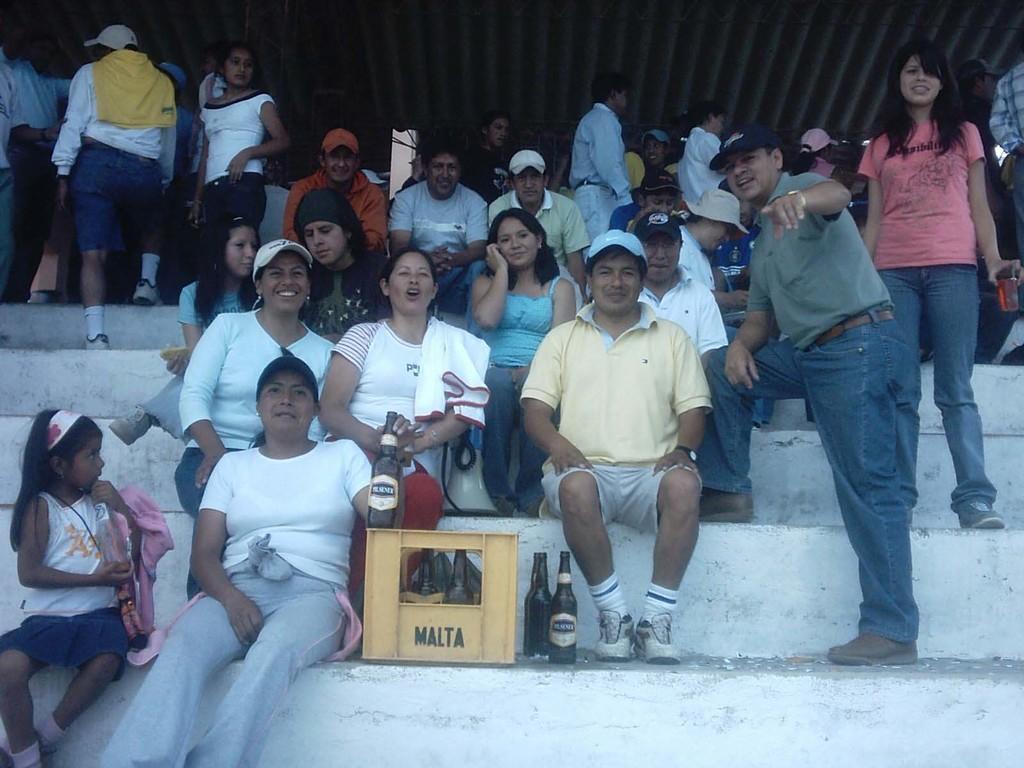Please provide a concise description of this image. In the image we can see there are many people wearing clothes and shoes, and some of them are wearing a cap. They are sitting on the stairs and some of them are standing. This is a container and bottles, these are the stairs and wrist watch. 